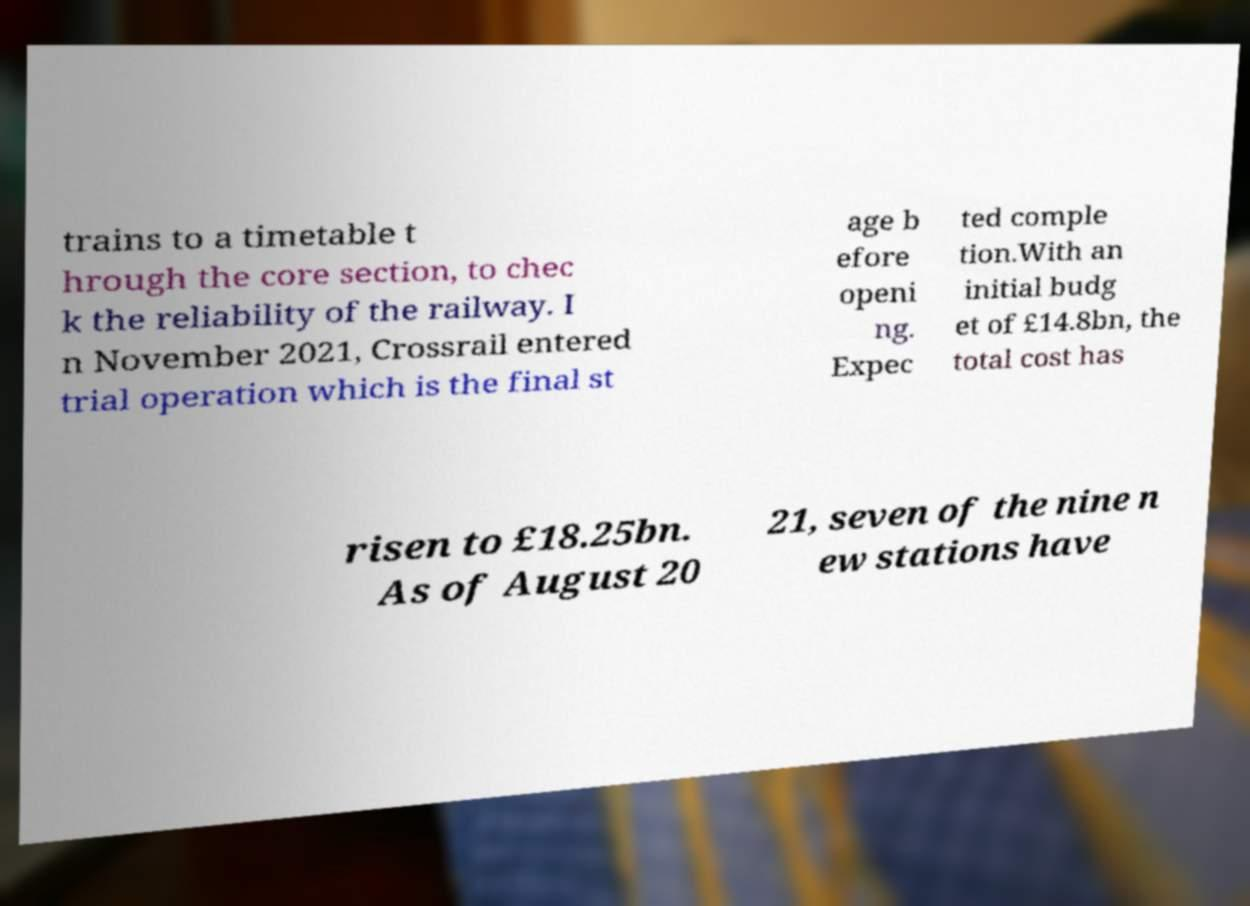I need the written content from this picture converted into text. Can you do that? trains to a timetable t hrough the core section, to chec k the reliability of the railway. I n November 2021, Crossrail entered trial operation which is the final st age b efore openi ng. Expec ted comple tion.With an initial budg et of £14.8bn, the total cost has risen to £18.25bn. As of August 20 21, seven of the nine n ew stations have 